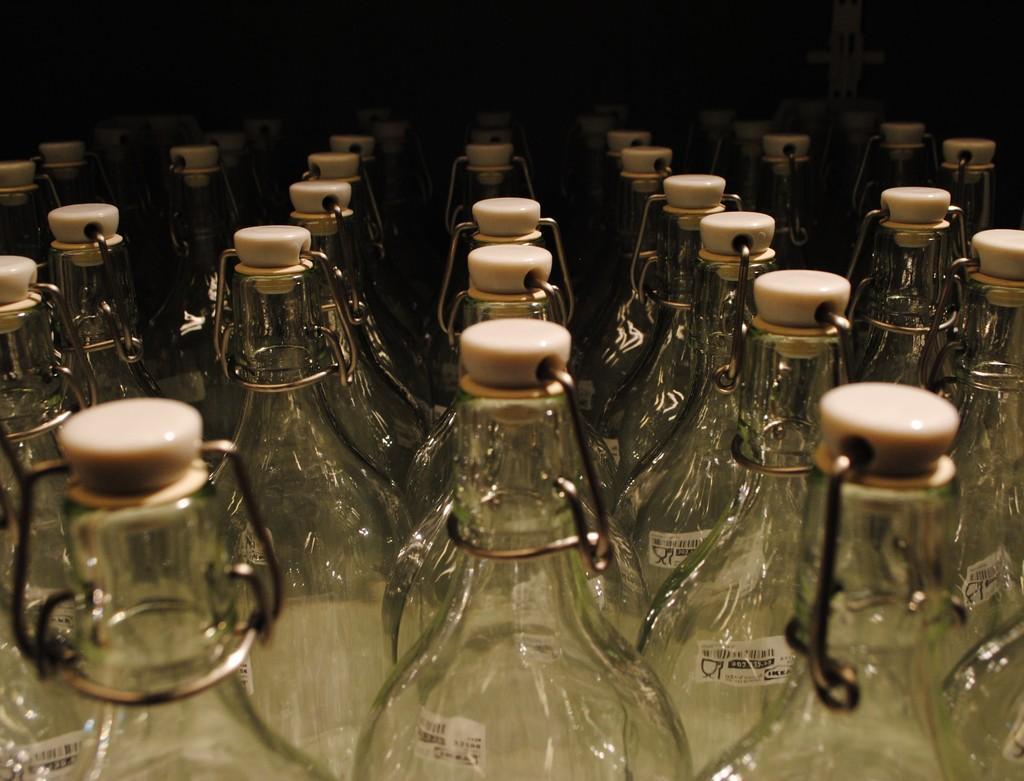Can you describe this image briefly? There are so many bottles. The bottle has a sticker. The bottle has a cap. 